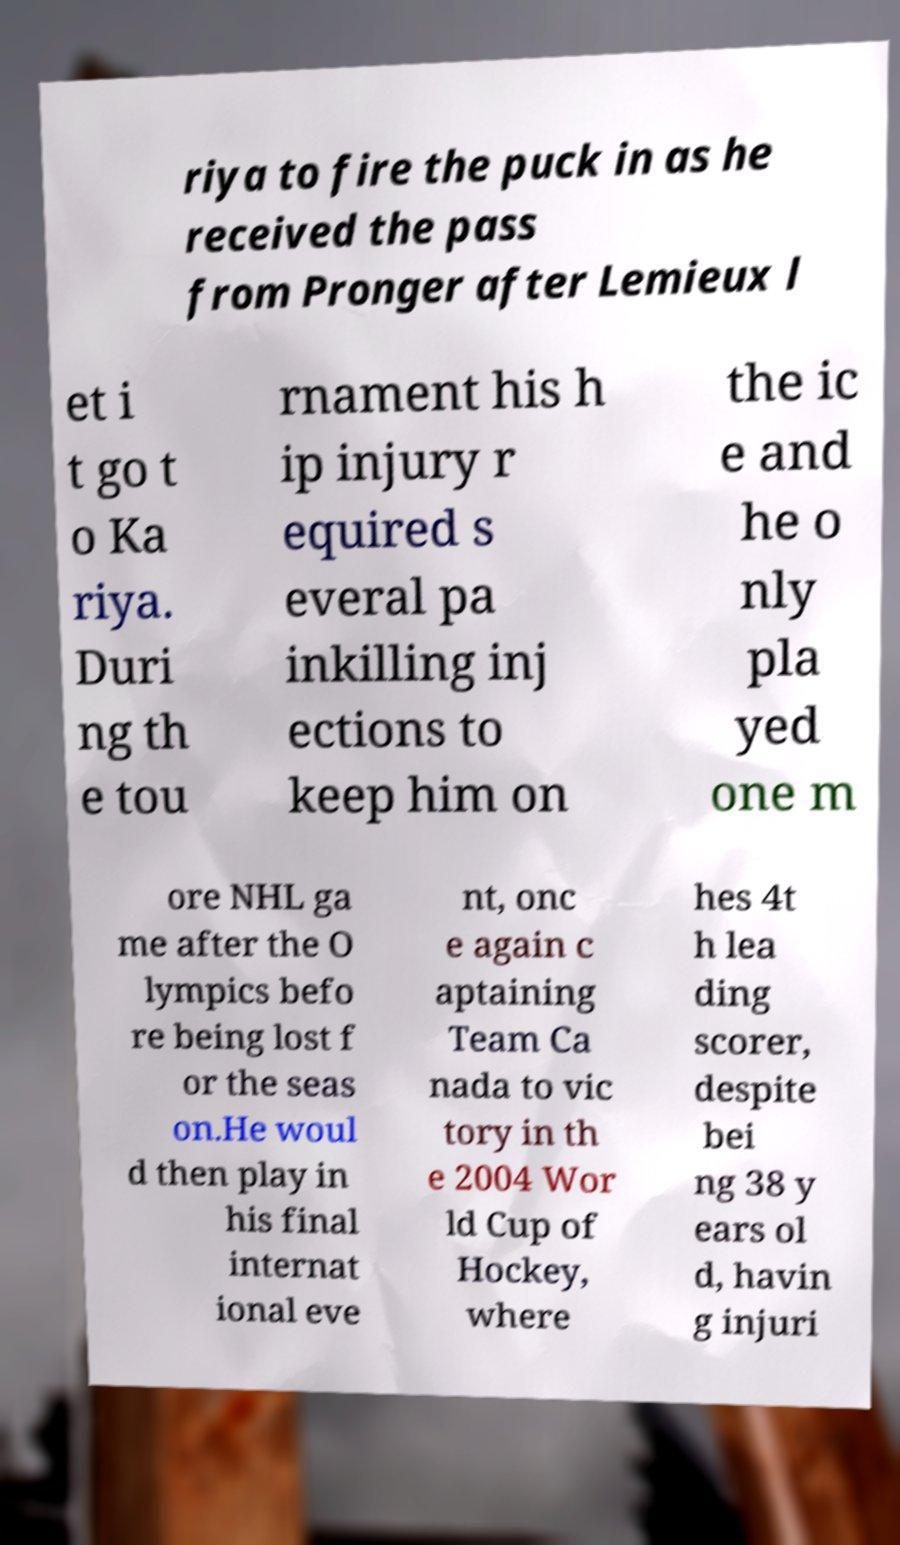What messages or text are displayed in this image? I need them in a readable, typed format. riya to fire the puck in as he received the pass from Pronger after Lemieux l et i t go t o Ka riya. Duri ng th e tou rnament his h ip injury r equired s everal pa inkilling inj ections to keep him on the ic e and he o nly pla yed one m ore NHL ga me after the O lympics befo re being lost f or the seas on.He woul d then play in his final internat ional eve nt, onc e again c aptaining Team Ca nada to vic tory in th e 2004 Wor ld Cup of Hockey, where hes 4t h lea ding scorer, despite bei ng 38 y ears ol d, havin g injuri 